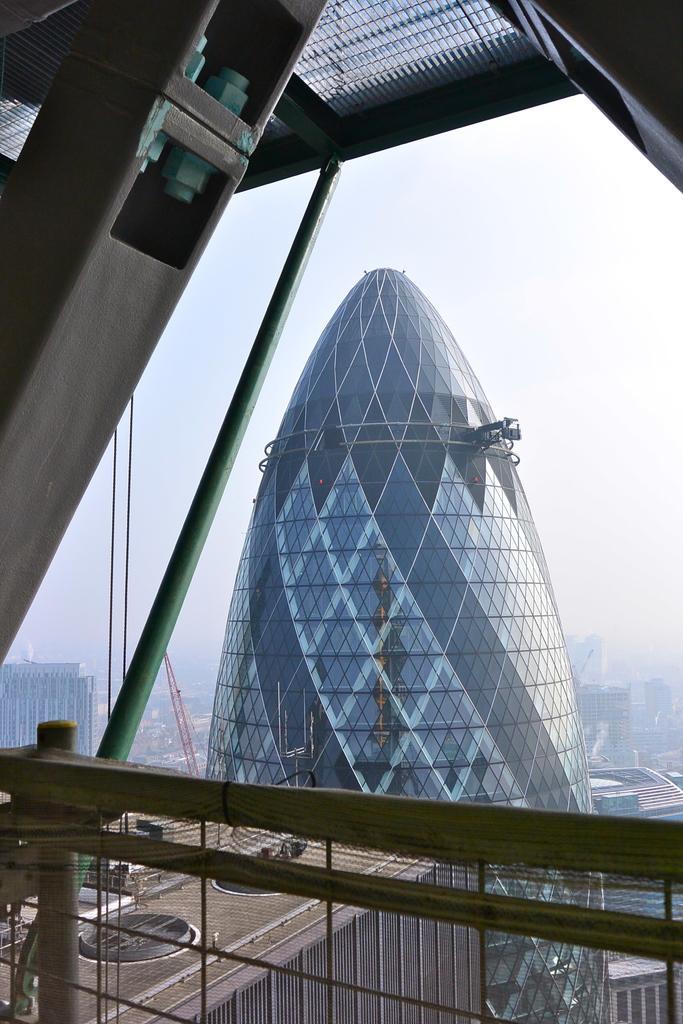Please provide a concise description of this image. In this image there are buildings. Bottom of the image there is a fence. A metal rod is attached to the roof. Background there is sky. 